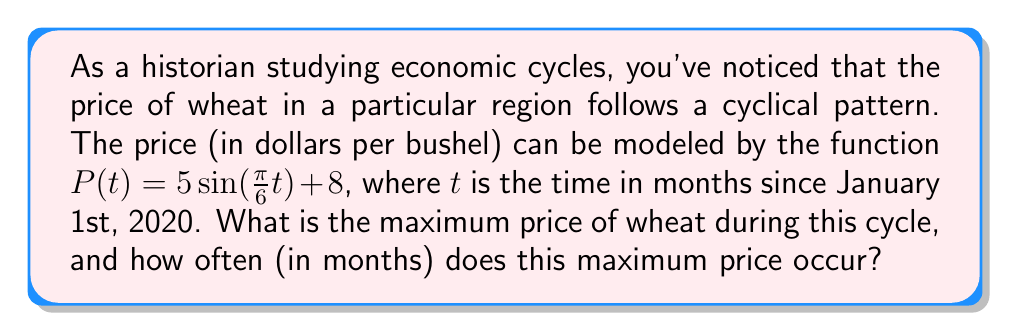Help me with this question. Let's approach this step-by-step:

1) The given function is of the form $a\sin(bt) + c$, where:
   $a = 5$ (amplitude)
   $b = \frac{\pi}{6}$ (angular frequency)
   $c = 8$ (vertical shift)

2) In a sine function, the maximum value occurs when $\sin(bt) = 1$.

3) The maximum value of the function will be:
   $P_{max} = a + c = 5 + 8 = 13$

4) To find how often this maximum occurs, we need to calculate the period of the function.

5) The period of a sine function is given by $\frac{2\pi}{|b|}$. In this case:

   Period = $\frac{2\pi}{|\frac{\pi}{6}|} = \frac{2\pi}{\frac{\pi}{6}} = 2 * 6 = 12$ months

6) This means the maximum price occurs every 12 months.
Answer: Maximum price: $13 per bushel; Occurs every 12 months 